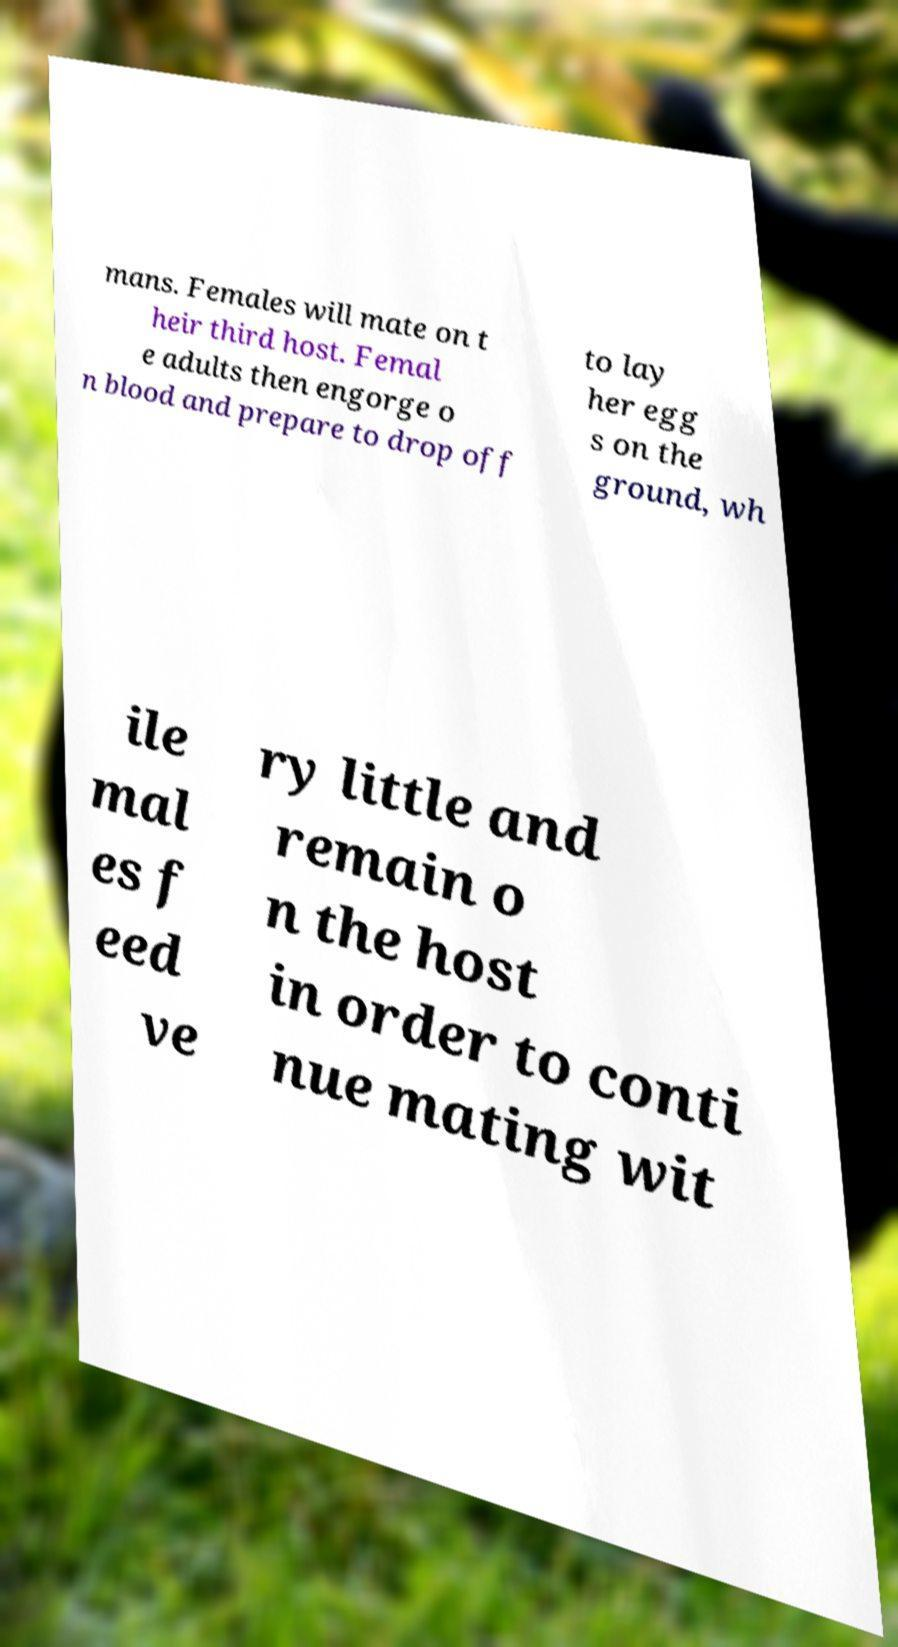Please identify and transcribe the text found in this image. mans. Females will mate on t heir third host. Femal e adults then engorge o n blood and prepare to drop off to lay her egg s on the ground, wh ile mal es f eed ve ry little and remain o n the host in order to conti nue mating wit 